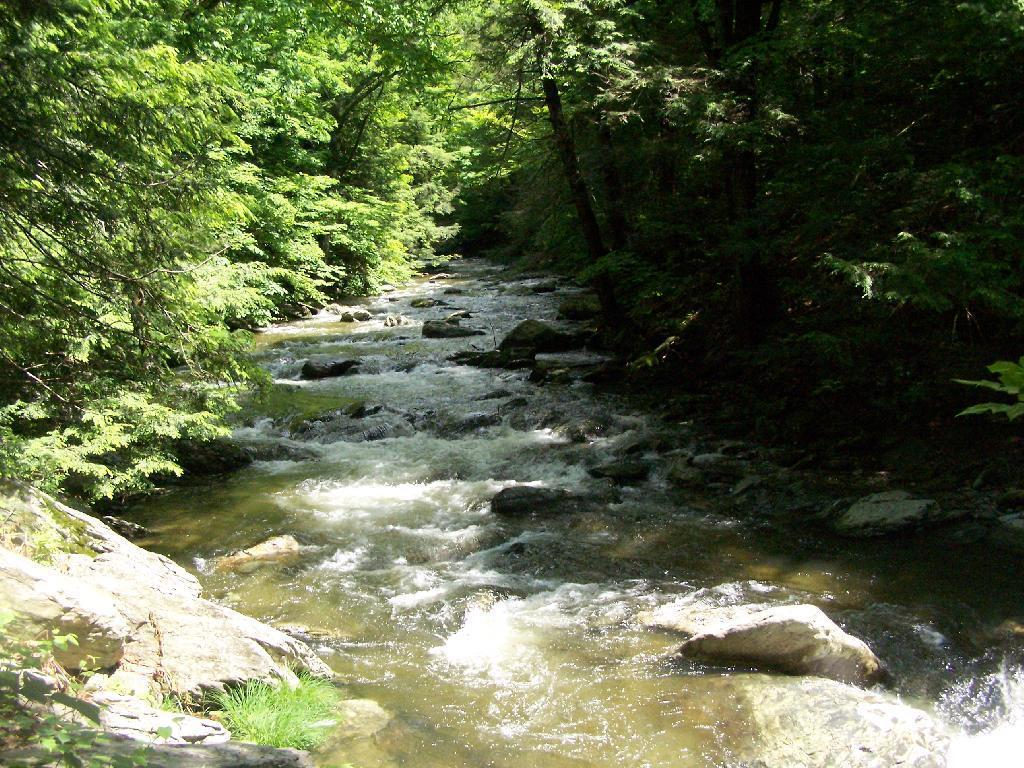What is the primary feature of the image? The primary feature of the image is the presence of many trees. Can you describe the water in the image? Yes, there is water visible in the image, and it is located in the center. How many people are smiling while flying kites in the image? There are no people or kites present in the image; it primarily features trees and water. Can you describe the servant's attire in the image? There is no servant present in the image, as it primarily features trees and water. 